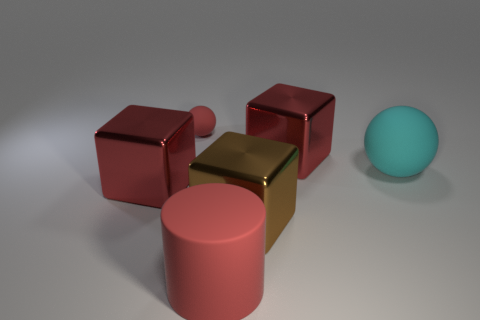Is there any other thing that has the same size as the red rubber ball?
Your answer should be very brief. No. How many red objects are either big cubes or big matte cylinders?
Your answer should be very brief. 3. Is there a big shiny ball that has the same color as the cylinder?
Offer a very short reply. No. The cyan object that is made of the same material as the small ball is what size?
Keep it short and to the point. Large. What number of balls are cyan matte objects or large brown things?
Keep it short and to the point. 1. Is the number of green objects greater than the number of big cyan rubber spheres?
Ensure brevity in your answer.  No. What number of spheres are the same size as the cyan matte thing?
Your response must be concise. 0. There is a big matte thing that is the same color as the tiny ball; what is its shape?
Your response must be concise. Cylinder. What number of things are either tiny red balls behind the large brown cube or red things?
Your answer should be compact. 4. Are there fewer big cyan matte spheres than big gray cylinders?
Make the answer very short. No. 